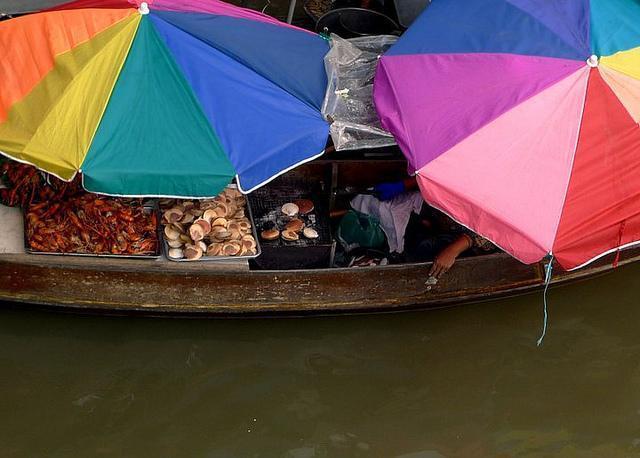How many umbrellas are there?
Give a very brief answer. 2. How many white and green surfboards are in the image?
Give a very brief answer. 0. 